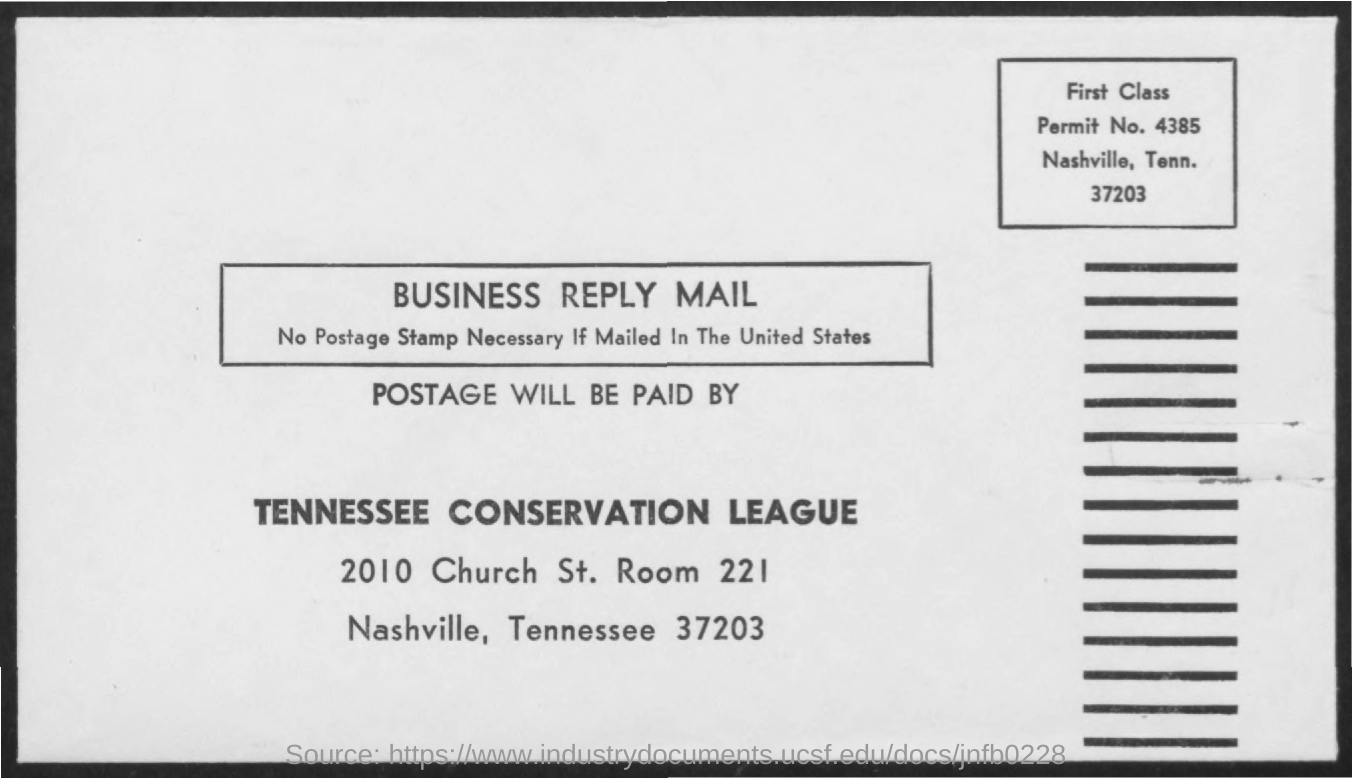What is the name of the league ?
Your response must be concise. Tennessee conservation league. What is the room no mentioned ?
Make the answer very short. 221. Postage will be paid by whom ?
Your answer should be compact. TENNESSEE  CONSERVATION LEAGUE. What is the permit no mentioned ?
Your answer should be very brief. 4385. 